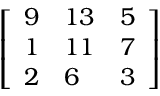<formula> <loc_0><loc_0><loc_500><loc_500>\left [ \begin{array} { l l l } { 9 } & { 1 3 } & { 5 } \\ { 1 } & { 1 1 } & { 7 } \\ { 2 } & { 6 } & { 3 } \end{array} \right ]</formula> 